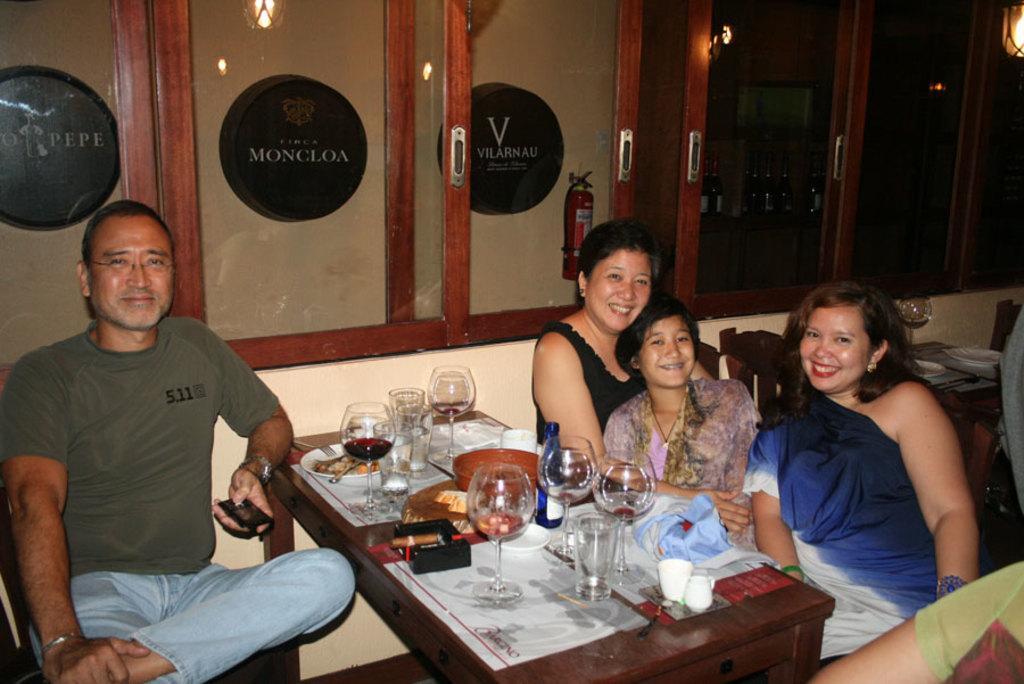How would you summarize this image in a sentence or two? It seems to be the image is inside the restaurant. In the image there are four people sitting on chair in front of a table. On table we can see a glass with some liquid content,plate,spoon,food,cloth in background there is a window which is closed and a fire extinguisher. 